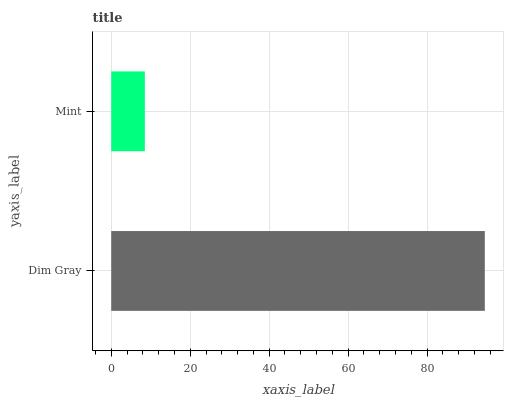Is Mint the minimum?
Answer yes or no. Yes. Is Dim Gray the maximum?
Answer yes or no. Yes. Is Mint the maximum?
Answer yes or no. No. Is Dim Gray greater than Mint?
Answer yes or no. Yes. Is Mint less than Dim Gray?
Answer yes or no. Yes. Is Mint greater than Dim Gray?
Answer yes or no. No. Is Dim Gray less than Mint?
Answer yes or no. No. Is Dim Gray the high median?
Answer yes or no. Yes. Is Mint the low median?
Answer yes or no. Yes. Is Mint the high median?
Answer yes or no. No. Is Dim Gray the low median?
Answer yes or no. No. 